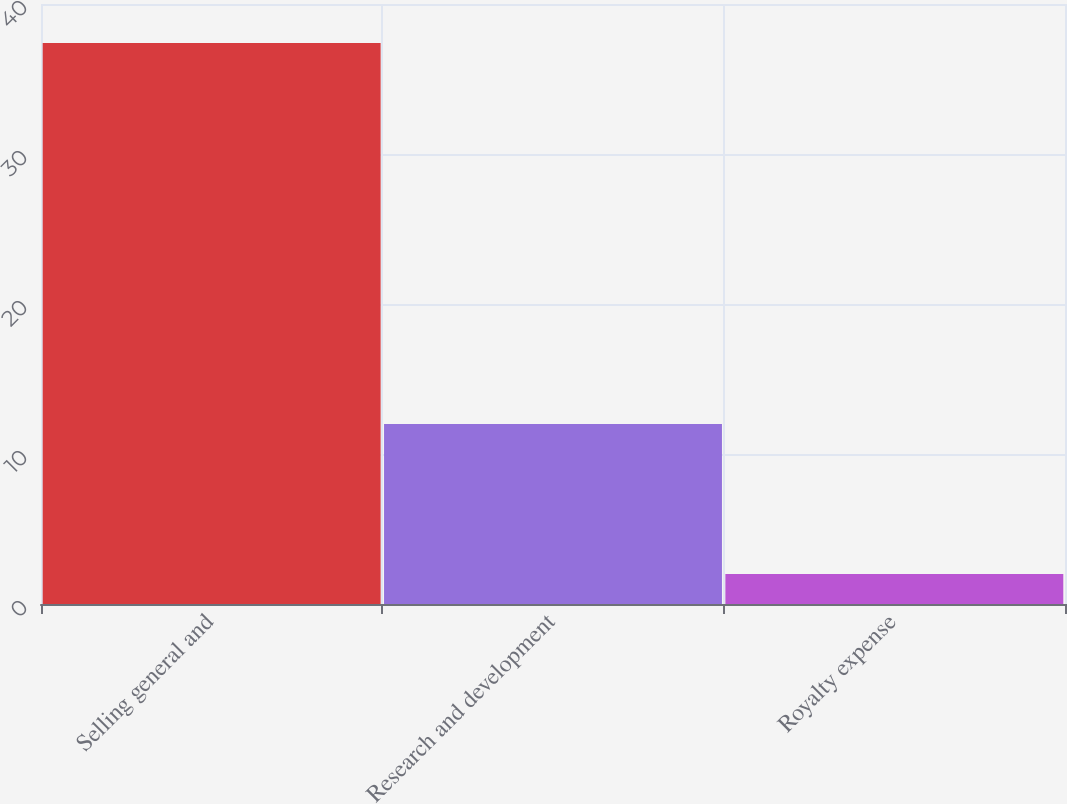Convert chart to OTSL. <chart><loc_0><loc_0><loc_500><loc_500><bar_chart><fcel>Selling general and<fcel>Research and development<fcel>Royalty expense<nl><fcel>37.4<fcel>12<fcel>2<nl></chart> 